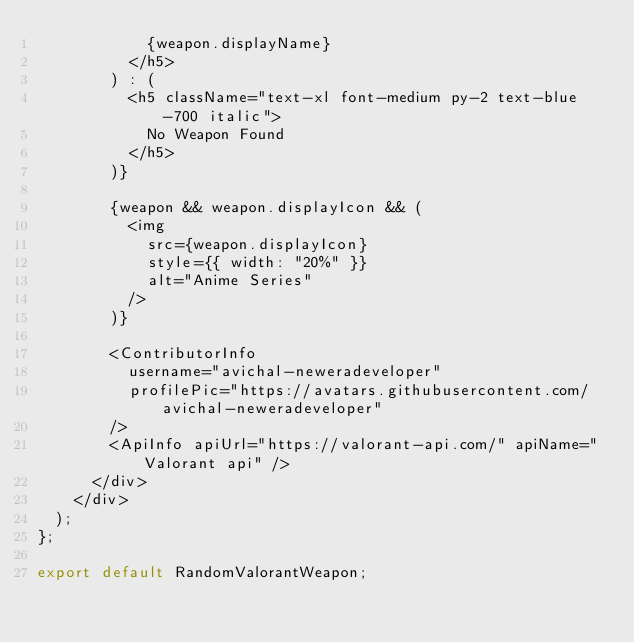<code> <loc_0><loc_0><loc_500><loc_500><_JavaScript_>            {weapon.displayName}
          </h5>
        ) : (
          <h5 className="text-xl font-medium py-2 text-blue-700 italic">
            No Weapon Found
          </h5>
        )}

        {weapon && weapon.displayIcon && (
          <img
            src={weapon.displayIcon}
            style={{ width: "20%" }}
            alt="Anime Series"
          />
        )}

        <ContributorInfo
          username="avichal-neweradeveloper"
          profilePic="https://avatars.githubusercontent.com/avichal-neweradeveloper"
        />
        <ApiInfo apiUrl="https://valorant-api.com/" apiName="Valorant api" />
      </div>
    </div>
  );
};

export default RandomValorantWeapon;
</code> 